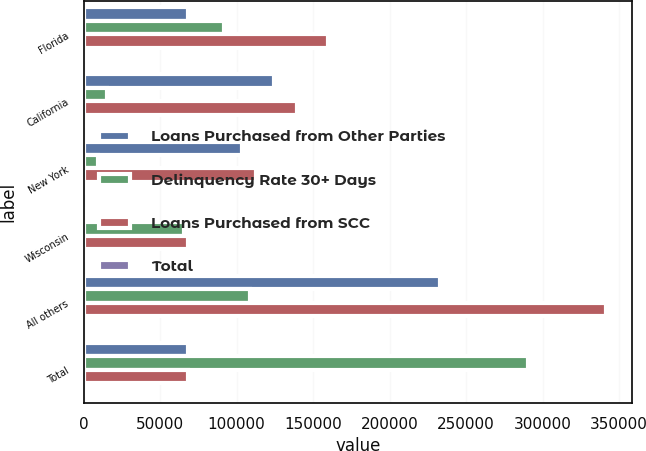<chart> <loc_0><loc_0><loc_500><loc_500><stacked_bar_chart><ecel><fcel>Florida<fcel>California<fcel>New York<fcel>Wisconsin<fcel>All others<fcel>Total<nl><fcel>Loans Purchased from Other Parties<fcel>68080<fcel>124750<fcel>103325<fcel>2241<fcel>232837<fcel>68101.5<nl><fcel>Delinquency Rate 30+ Days<fcel>91707<fcel>14965<fcel>9386<fcel>65882<fcel>108664<fcel>290604<nl><fcel>Loans Purchased from SCC<fcel>159787<fcel>139715<fcel>112711<fcel>68123<fcel>341501<fcel>68101.5<nl><fcel>Total<fcel>19.4<fcel>17<fcel>13.7<fcel>8.3<fcel>41.6<fcel>100<nl></chart> 